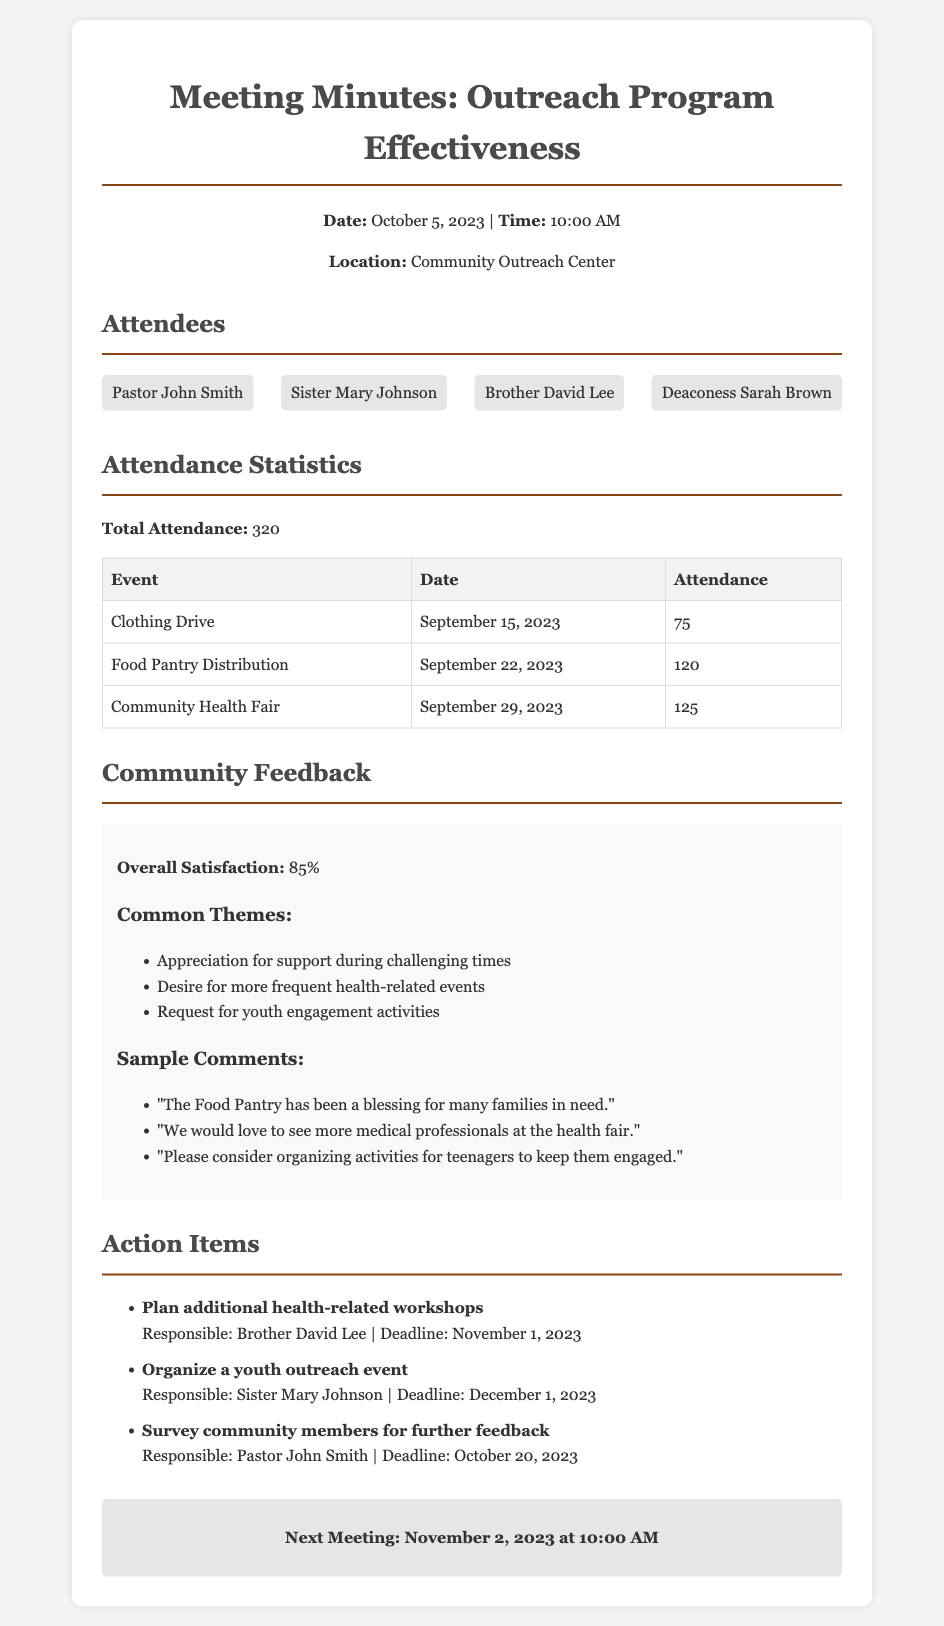What is the date of the meeting? The date of the meeting is mentioned at the top of the document.
Answer: October 5, 2023 How many people attended the Food Pantry Distribution event? The attendance for the Food Pantry Distribution is listed in the Attendance Statistics section.
Answer: 120 What is the overall satisfaction percentage from community feedback? The overall satisfaction percentage is explicitly stated in the Community Feedback section.
Answer: 85% Who is responsible for planning additional health-related workshops? The responsible person is mentioned next to the action item in the Action Items section.
Answer: Brother David Lee What common theme reflects the community's desire for activities? The theme that reflects the community's desire is listed in the Community Feedback section.
Answer: More frequent health-related events How many total attendees were recorded for all events combined? The total attendance is summarized in the Attendance Statistics section.
Answer: 320 What is the next meeting date? The date of the next meeting is provided at the end of the document.
Answer: November 2, 2023 Which event had the highest attendance? The event with the highest attendance is identified in the Attendance Statistics table.
Answer: Community Health Fair What type of feedback did the community provide about the Food Pantry? The feedback about the Food Pantry is given in the Sample Comments list.
Answer: A blessing for many families in need 